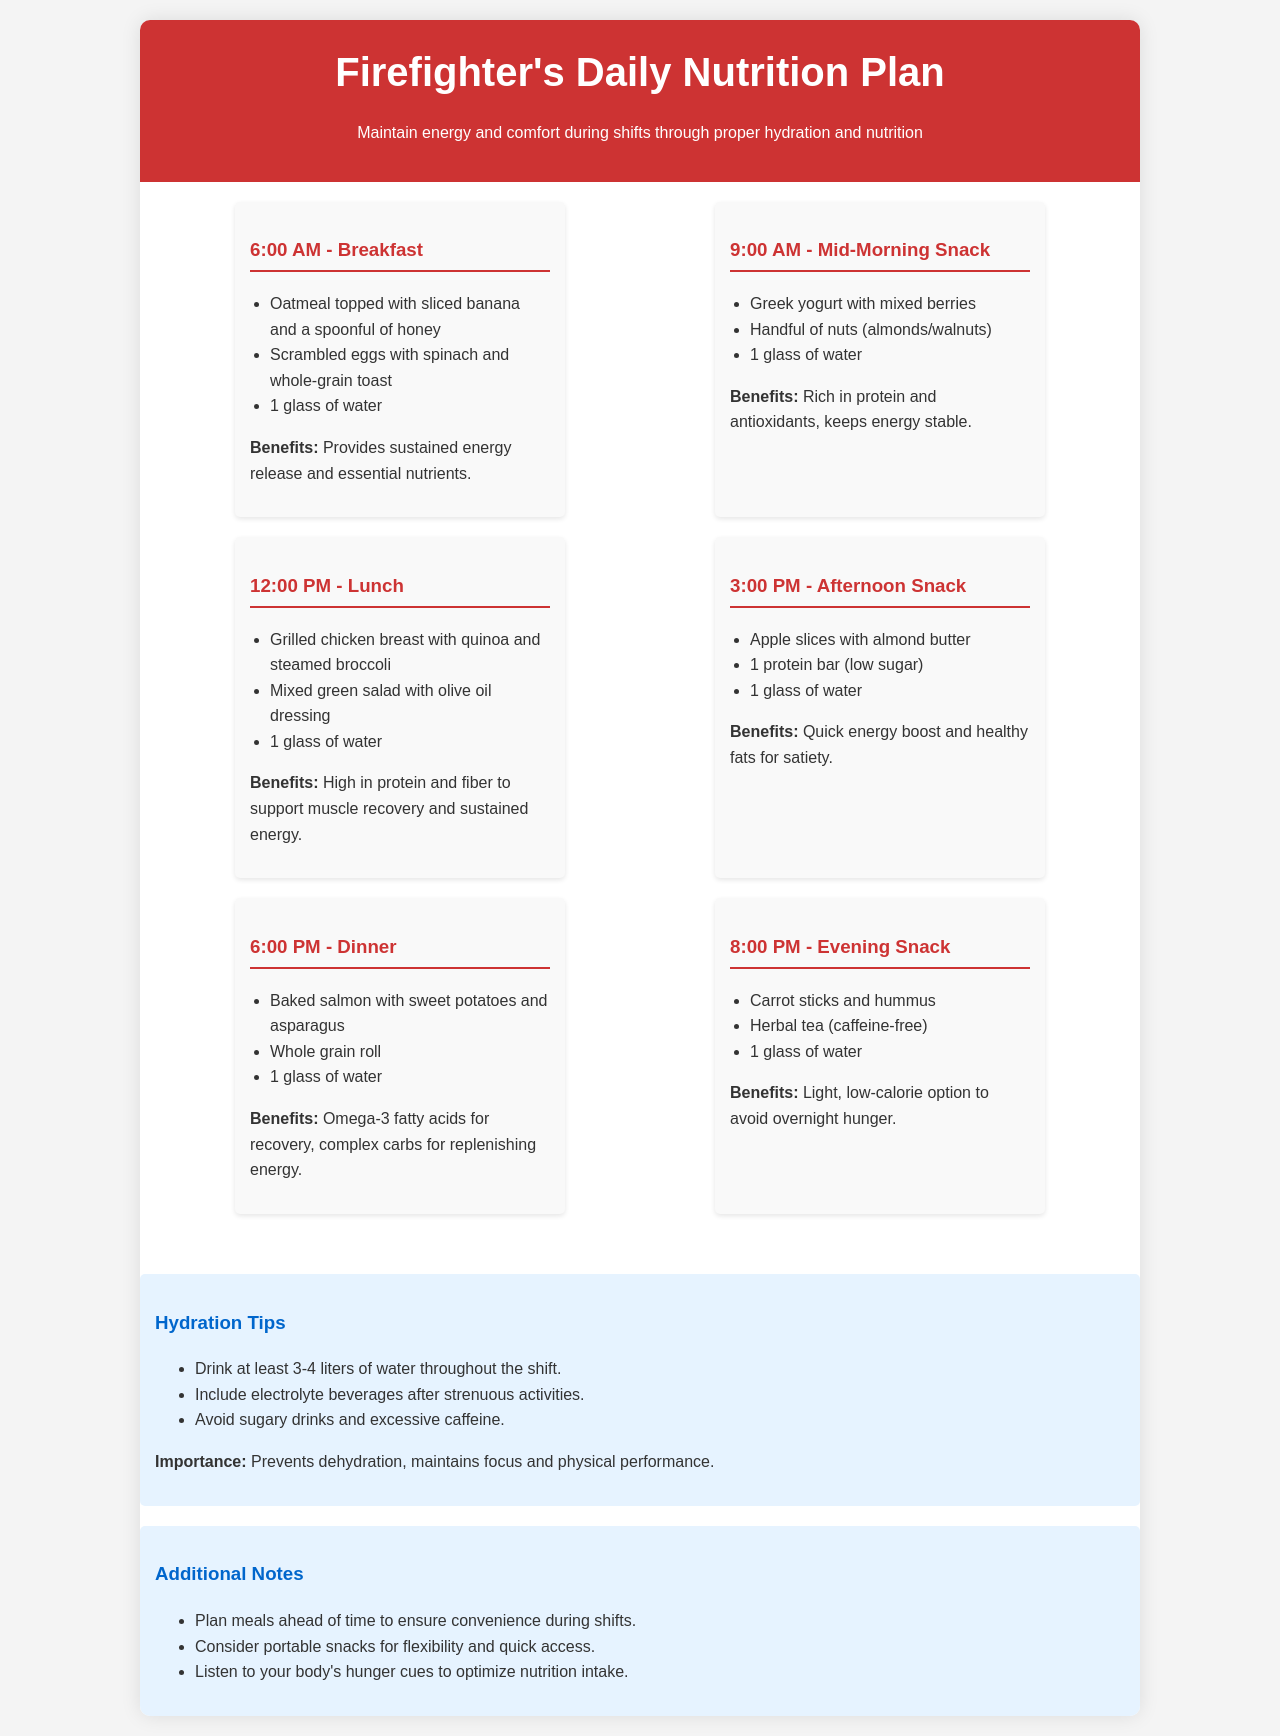What is served for breakfast? Breakfast includes oatmeal topped with sliced banana and a spoonful of honey, scrambled eggs with spinach, and whole-grain toast.
Answer: Oatmeal topped with sliced banana and a spoonful of honey, scrambled eggs with spinach, whole-grain toast How many liters of water should be consumed during the shift? The hydration tips recommend drinking at least 3-4 liters of water throughout the shift.
Answer: 3-4 liters What kind of snack is suggested for the afternoon? The afternoon snack includes apple slices with almond butter, a protein bar (low sugar), and water.
Answer: Apple slices with almond butter What are some benefits of the mid-morning snack? The mid-morning snack is rich in protein and antioxidants, which keeps energy stable.
Answer: Rich in protein and antioxidants What is the time for dinner in this plan? The dinner is scheduled for 6:00 PM according to the daily nutrition plan.
Answer: 6:00 PM What type of beverage is recommended after strenuous activities? The hydration tips mention including electrolyte beverages after strenuous activities.
Answer: Electrolyte beverages What is suggested to avoid during hydration? The hydration tips suggest avoiding sugary drinks and excessive caffeine.
Answer: Sugary drinks and excessive caffeine What is an important consideration when planning meals? The additional notes recommend planning meals ahead of time to ensure convenience during shifts.
Answer: Convenience during shifts 